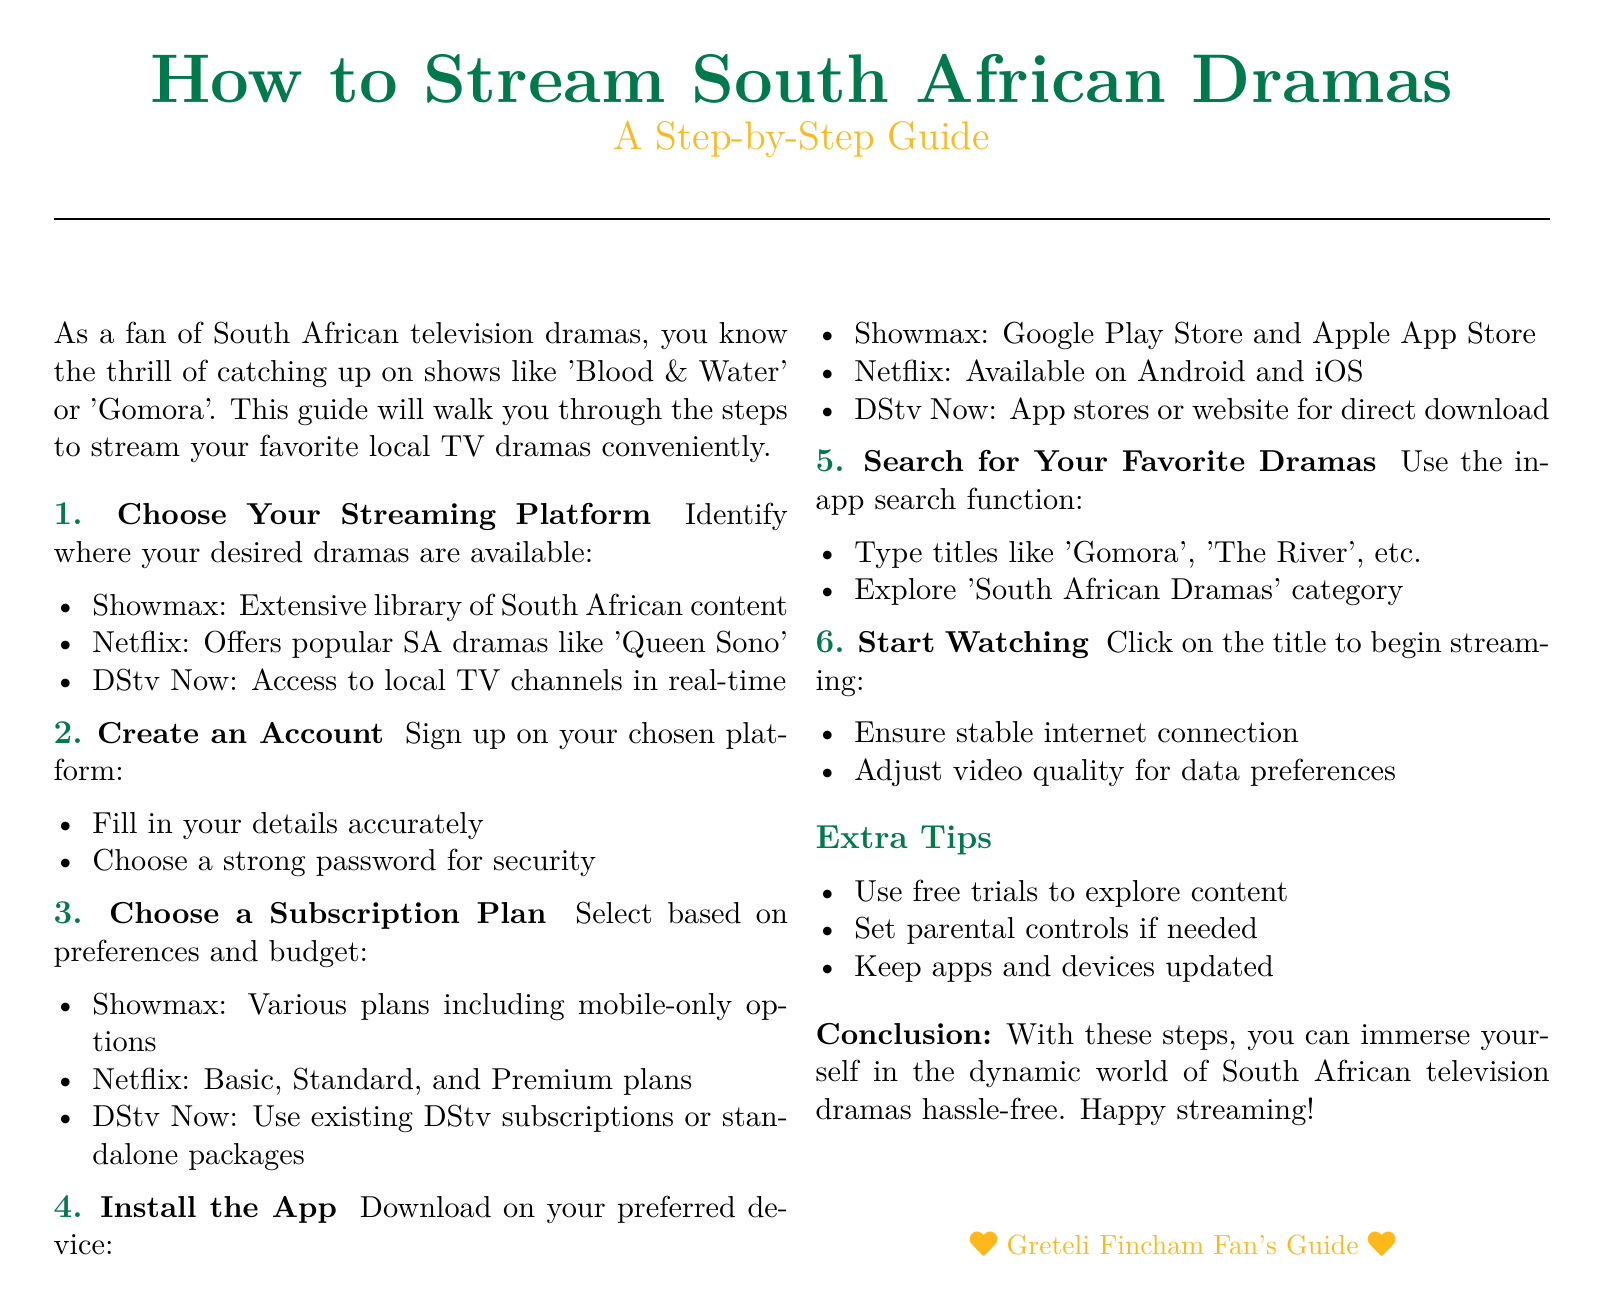What are some streaming platforms for South African dramas? The document lists several platforms where South African dramas can be streamed, specifically mentioning Showmax, Netflix, and DStv Now.
Answer: Showmax, Netflix, DStv Now What should you do first to start streaming? The initial step outlined in the document is to choose a streaming platform where the desired dramas are available.
Answer: Choose Your Streaming Platform What is required when creating an account? The guide specifies that you need to fill in your details accurately and choose a strong password for security.
Answer: Fill in details, strong password What is one of the subscription plans offered by Netflix? The document mentions basic, standard, and premium plans as options available for subscription on Netflix.
Answer: Basic, Standard, Premium What action is suggested for watching a specific drama? The document instructs that you should click on the title to begin streaming once you search for your favorite dramas.
Answer: Click on the title What should you do to enhance security during account setup? The document emphasizes choosing a strong password as part of creating an account to ensure security.
Answer: Choose a strong password How can you explore content on the chosen platform without committing financially? The guide suggests using free trials to explore the content available on streaming platforms.
Answer: Use free trials What must be ensured for a smooth streaming experience? It is recommended to ensure a stable internet connection while streaming to avoid interruptions.
Answer: Ensure stable internet connection 